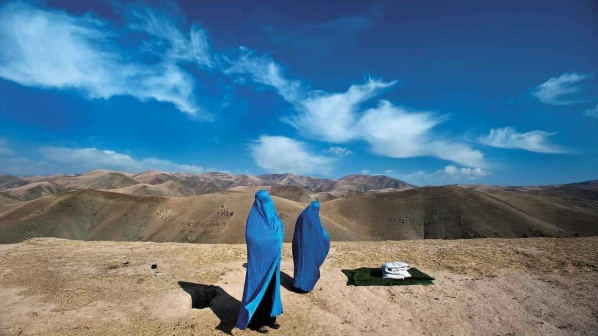How does the natural setting contribute to the overall mood of the image? The natural setting significantly enhances the mood of the image, contributing to a sense of tranquility and introspection. The vastness of the mountainous landscape imparts a feeling of insignificance and awe, reminding the viewer of nature's grandeur and immensity.

The clear blue sky with its delicate wisps of clouds evokes a serene and peaceful atmosphere, suggesting calmness and clarity. The rocky terrain underfoot adds a rugged, untamed aspect to the scene, suggesting that this is a place far removed from the bustle of everyday life. The panoramic views allow for open-minded contemplation, fostering a mood of reflection and connection to the natural world.

Overall, the setting works in harmony with the figures in the image to create a moment of pause, reflection, and peaceful interaction, underscored by the untouched beauty and serene isolation of the natural environment. 